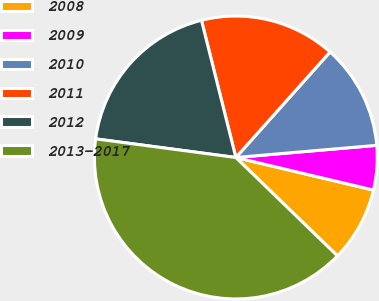Convert chart. <chart><loc_0><loc_0><loc_500><loc_500><pie_chart><fcel>2008<fcel>2009<fcel>2010<fcel>2011<fcel>2012<fcel>2013-2017<nl><fcel>8.55%<fcel>5.07%<fcel>12.03%<fcel>15.51%<fcel>18.99%<fcel>39.86%<nl></chart> 